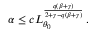<formula> <loc_0><loc_0><loc_500><loc_500>\alpha \leq c L _ { \theta _ { 0 } } ^ { \frac { q ( \beta + \gamma ) } { 2 + \gamma - q ( \beta + \gamma ) } } \, .</formula> 